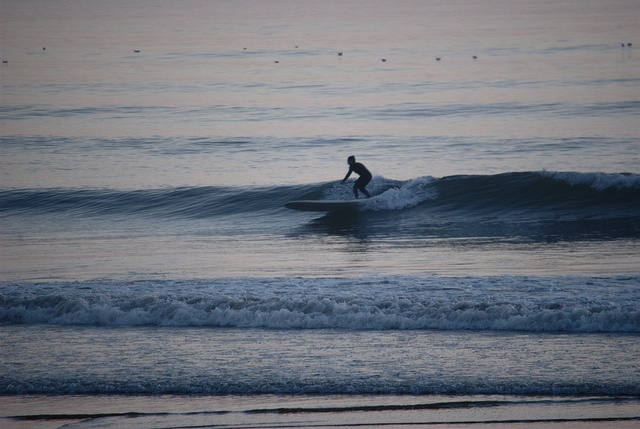Describe the objects in this image and their specific colors. I can see surfboard in gray, black, blue, and navy tones and people in gray, black, navy, and darkblue tones in this image. 